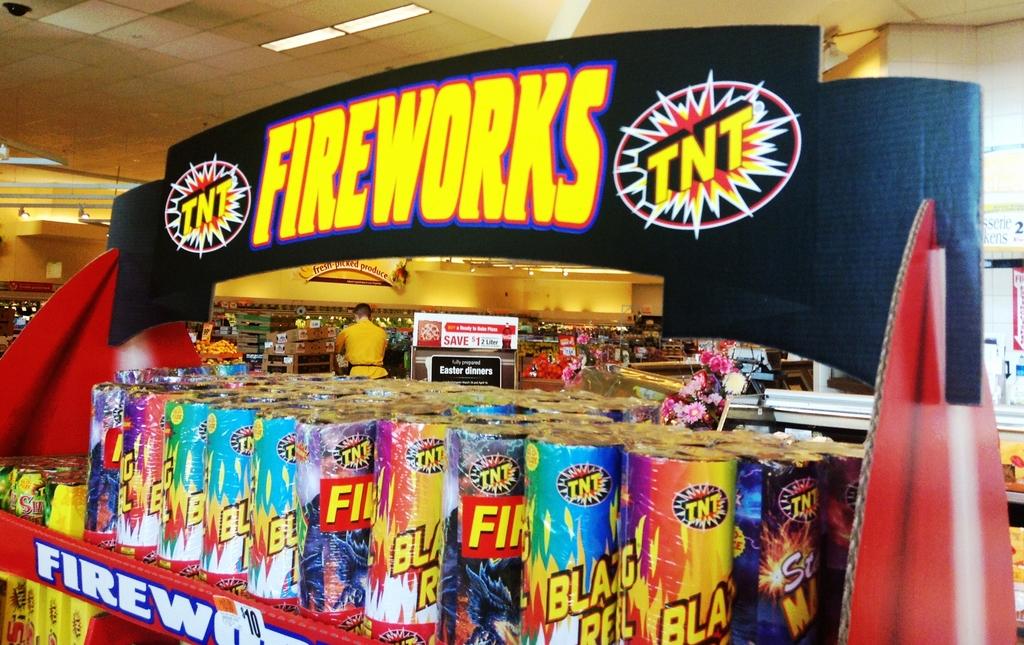What is being sold here?
Your answer should be compact. Fireworks. What type of explosive is used in the fireworks?
Your answer should be compact. Tnt. 